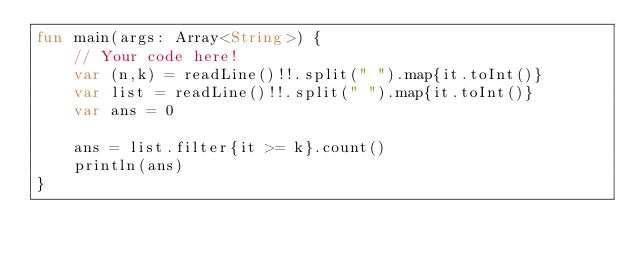<code> <loc_0><loc_0><loc_500><loc_500><_Kotlin_>fun main(args: Array<String>) {
    // Your code here!
    var (n,k) = readLine()!!.split(" ").map{it.toInt()}
    var list = readLine()!!.split(" ").map{it.toInt()}
    var ans = 0
    
    ans = list.filter{it >= k}.count()
    println(ans)
}
</code> 